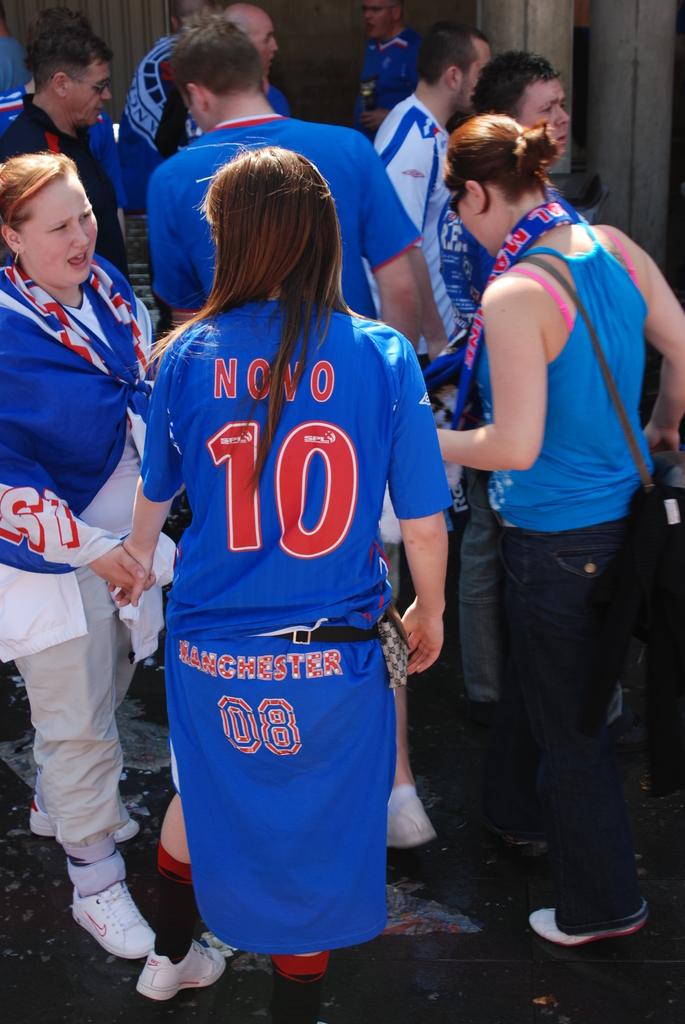What team do they play for?
Make the answer very short. Manchester. 